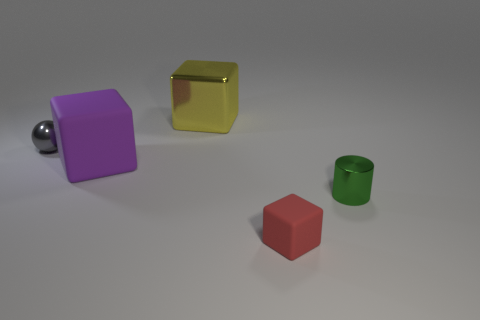What number of other things are the same color as the small matte object?
Your answer should be very brief. 0. How big is the metallic thing in front of the metallic thing that is left of the shiny object behind the small gray metallic object?
Make the answer very short. Small. There is a small gray shiny thing; are there any big metallic cubes in front of it?
Keep it short and to the point. No. There is a yellow object; is it the same size as the metallic thing that is in front of the purple rubber cube?
Offer a very short reply. No. What number of other objects are there of the same material as the small gray ball?
Your answer should be very brief. 2. The object that is both to the right of the big matte object and behind the large purple cube has what shape?
Offer a very short reply. Cube. Do the matte cube that is in front of the tiny cylinder and the block behind the small gray metallic thing have the same size?
Offer a terse response. No. What is the shape of the large thing that is the same material as the small red cube?
Provide a short and direct response. Cube. Is there anything else that has the same shape as the large purple thing?
Offer a very short reply. Yes. There is a object behind the gray metal ball left of the green thing that is in front of the yellow metal thing; what is its color?
Keep it short and to the point. Yellow. 